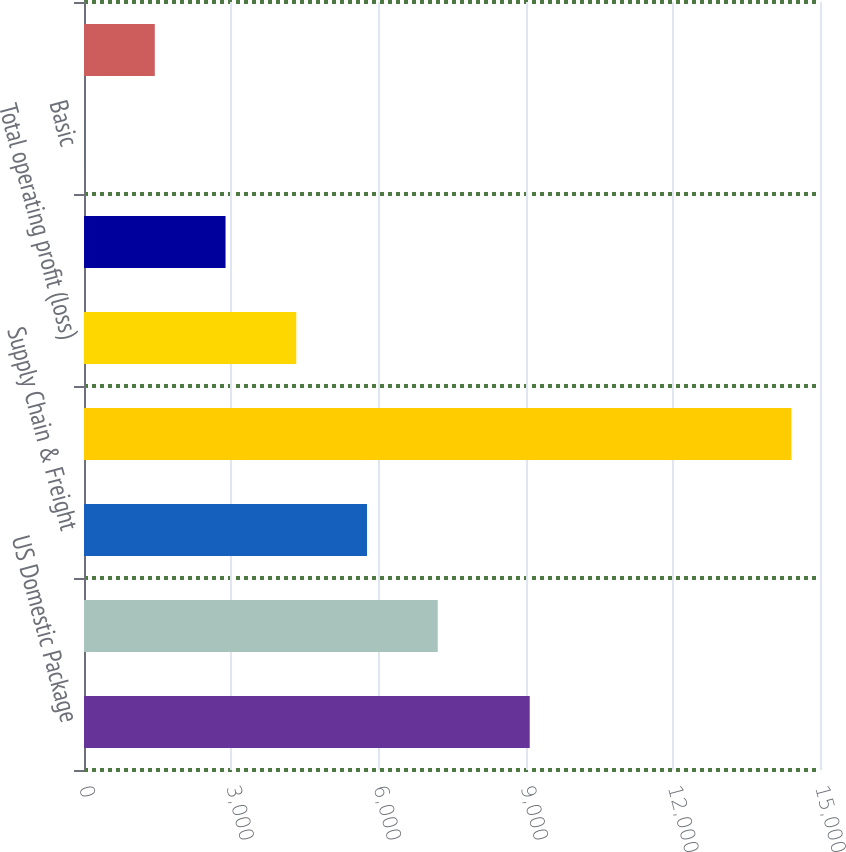<chart> <loc_0><loc_0><loc_500><loc_500><bar_chart><fcel>US Domestic Package<fcel>International Package<fcel>Supply Chain & Freight<fcel>Total revenue<fcel>Total operating profit (loss)<fcel>Net Income (Loss)<fcel>Basic<fcel>Diluted<nl><fcel>9084<fcel>7209.62<fcel>5767.95<fcel>14418<fcel>4326.28<fcel>2884.61<fcel>1.27<fcel>1442.94<nl></chart> 